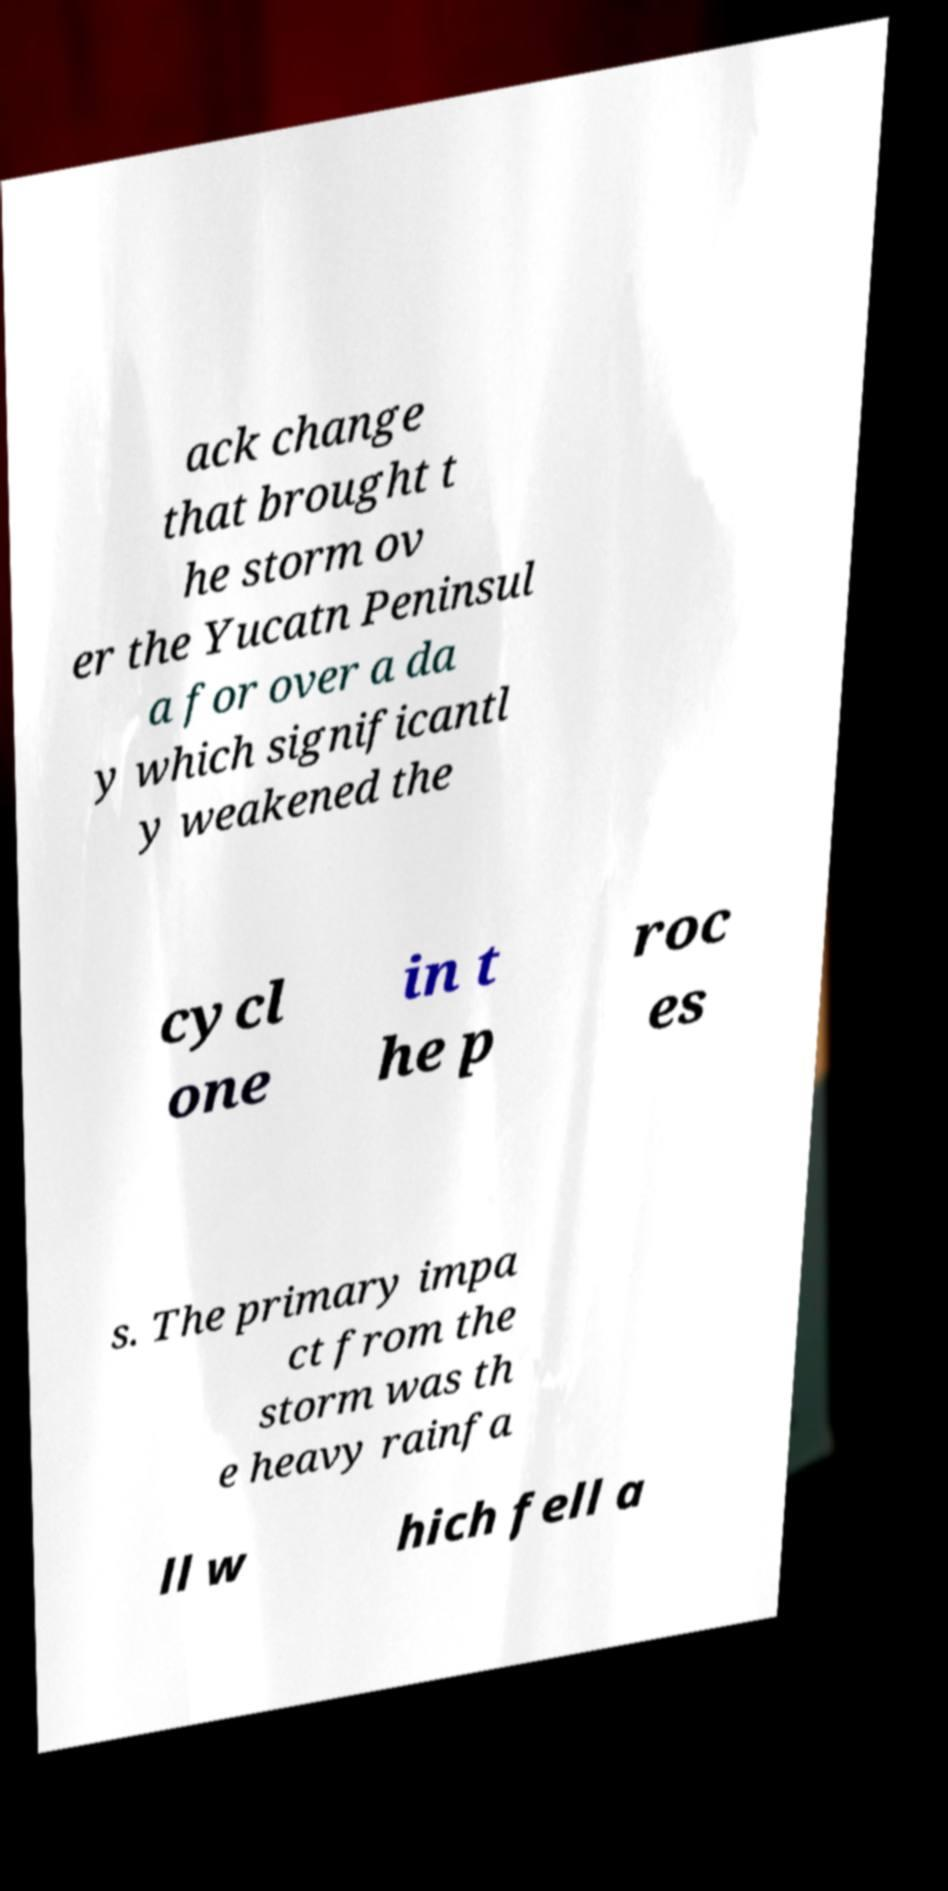I need the written content from this picture converted into text. Can you do that? ack change that brought t he storm ov er the Yucatn Peninsul a for over a da y which significantl y weakened the cycl one in t he p roc es s. The primary impa ct from the storm was th e heavy rainfa ll w hich fell a 